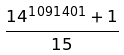Convert formula to latex. <formula><loc_0><loc_0><loc_500><loc_500>\frac { 1 4 ^ { 1 0 9 1 4 0 1 } + 1 } { 1 5 }</formula> 